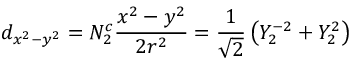Convert formula to latex. <formula><loc_0><loc_0><loc_500><loc_500>d _ { x ^ { 2 } - y ^ { 2 } } = N _ { 2 } ^ { c } { \frac { x ^ { 2 } - y ^ { 2 } } { 2 r ^ { 2 } } } = { \frac { 1 } { \sqrt { 2 } } } \left ( Y _ { 2 } ^ { - 2 } + Y _ { 2 } ^ { 2 } \right )</formula> 